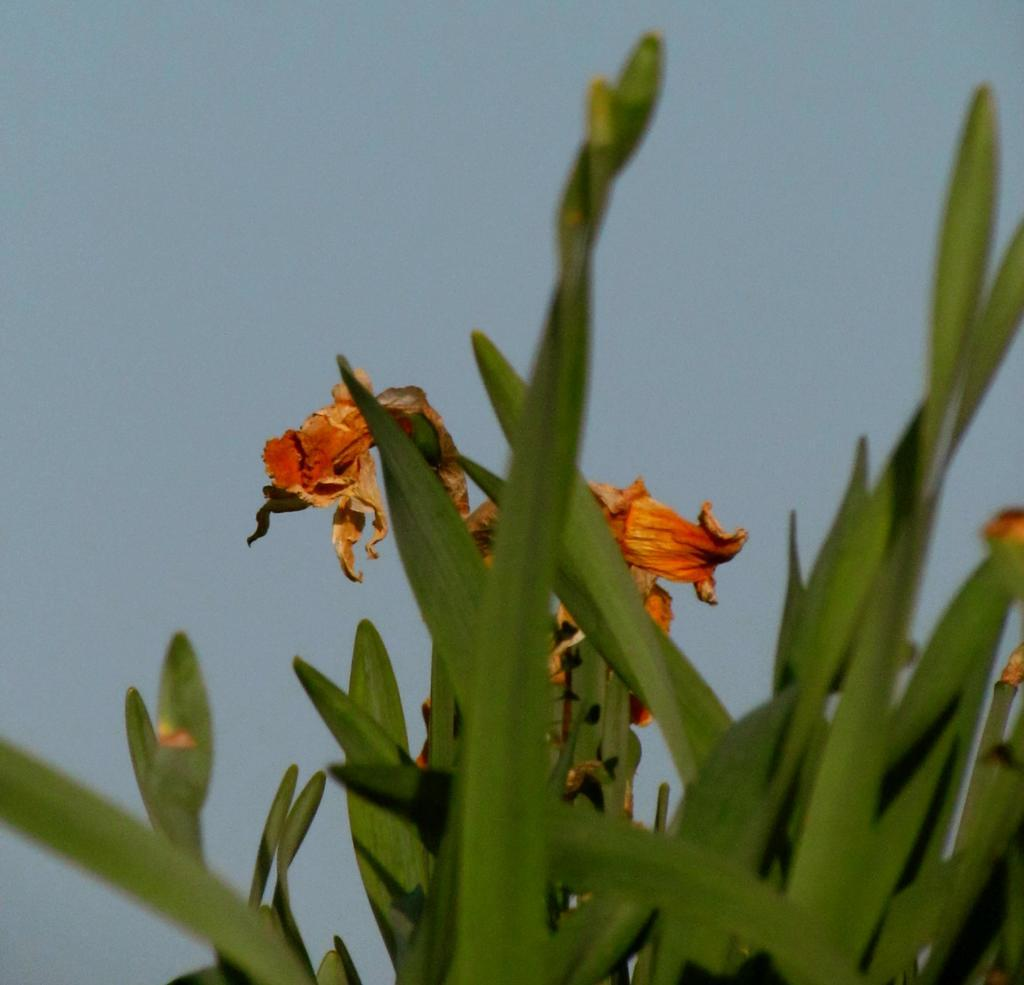What type of living organism can be seen in the image? There is a plant in the image. What is the color of the plant? The plant is green in color. Are there any additional features on the plant? Yes, there is a flower on the plant. What is the color of the flower? The flower is orange in color. What can be seen in the background of the image? The sky is visible in the background of the image. What type of news can be heard coming from the plant in the image? There is no news present in the image, as it features a plant with a flower and a green background. 